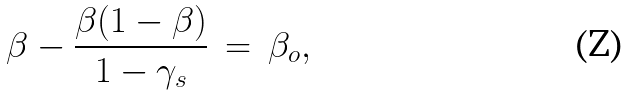Convert formula to latex. <formula><loc_0><loc_0><loc_500><loc_500>\beta - \frac { \beta ( 1 - \beta ) } { 1 - \gamma _ { s } } \, = \, \beta _ { o } ,</formula> 